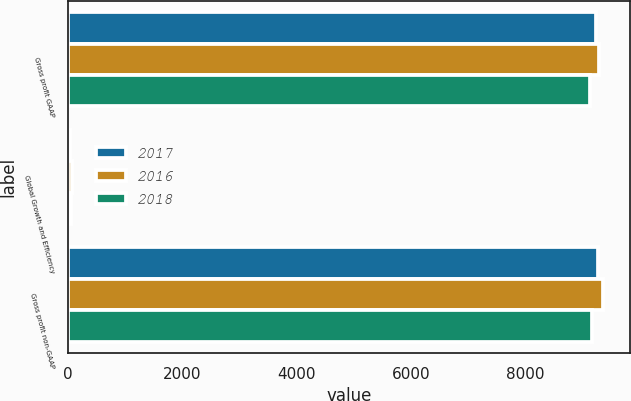Convert chart to OTSL. <chart><loc_0><loc_0><loc_500><loc_500><stacked_bar_chart><ecel><fcel>Gross profit GAAP<fcel>Global Growth and Efficiency<fcel>Gross profit non-GAAP<nl><fcel>2017<fcel>9231<fcel>31<fcel>9262<nl><fcel>2016<fcel>9280<fcel>75<fcel>9355<nl><fcel>2018<fcel>9123<fcel>46<fcel>9169<nl></chart> 